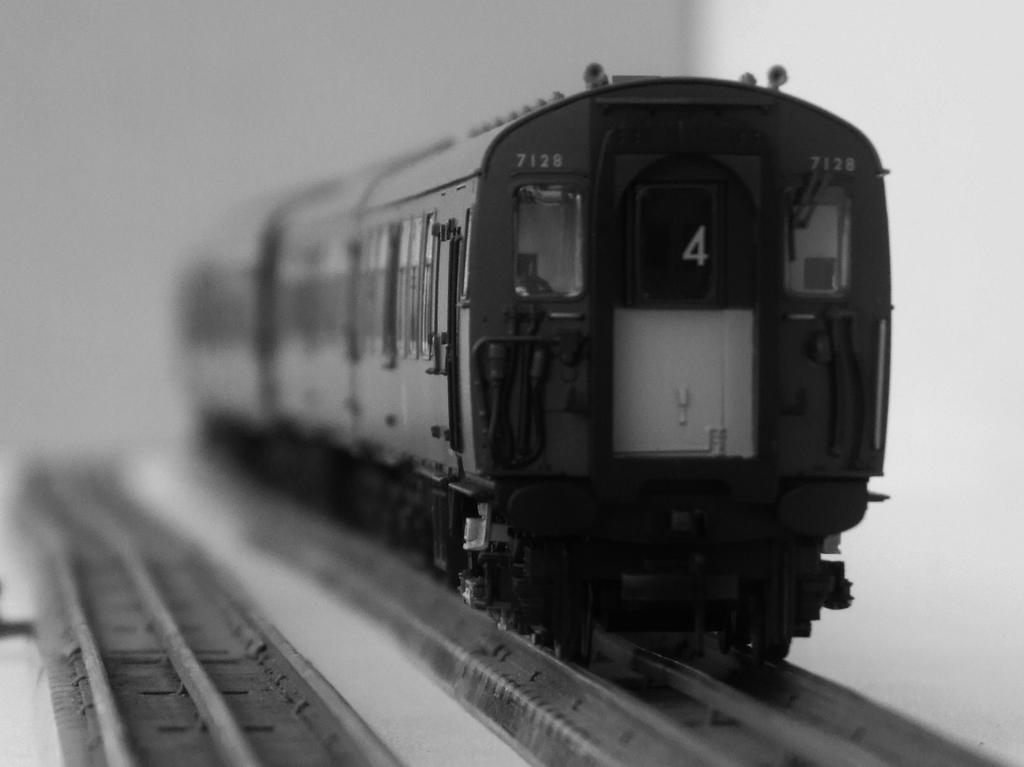What is the color scheme of the image? The image is black and white. What is the main subject of the image? There is a train in the image. Where is the train located in the image? The train is on a railway track. What can be seen on the left side of the image? There is another track on the left side of the image. How would you describe the background of the image? The background is blurred. Can you see the stranger's breath in the image? There is no stranger present in the image, so it is not possible to see their breath. 